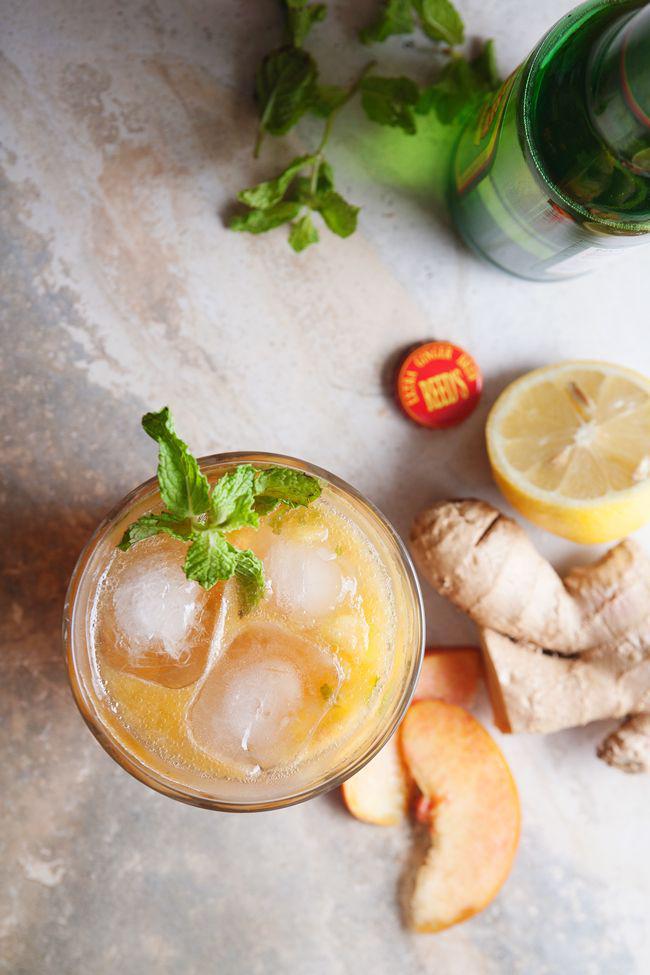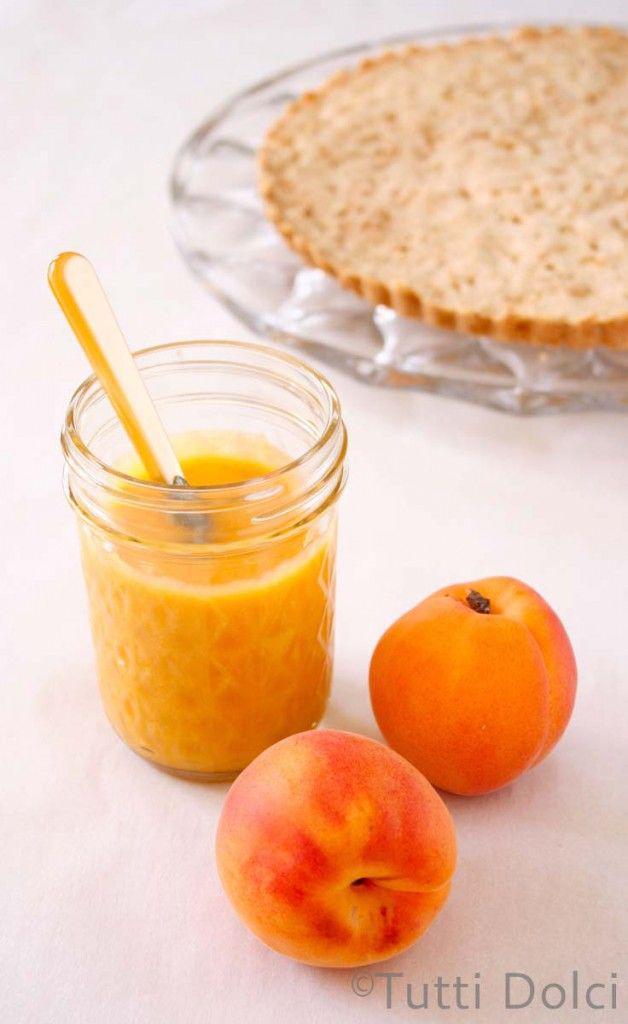The first image is the image on the left, the second image is the image on the right. Analyze the images presented: Is the assertion "An image shows at least one glass of creamy peach-colored beverage next to peach fruit." valid? Answer yes or no. Yes. 